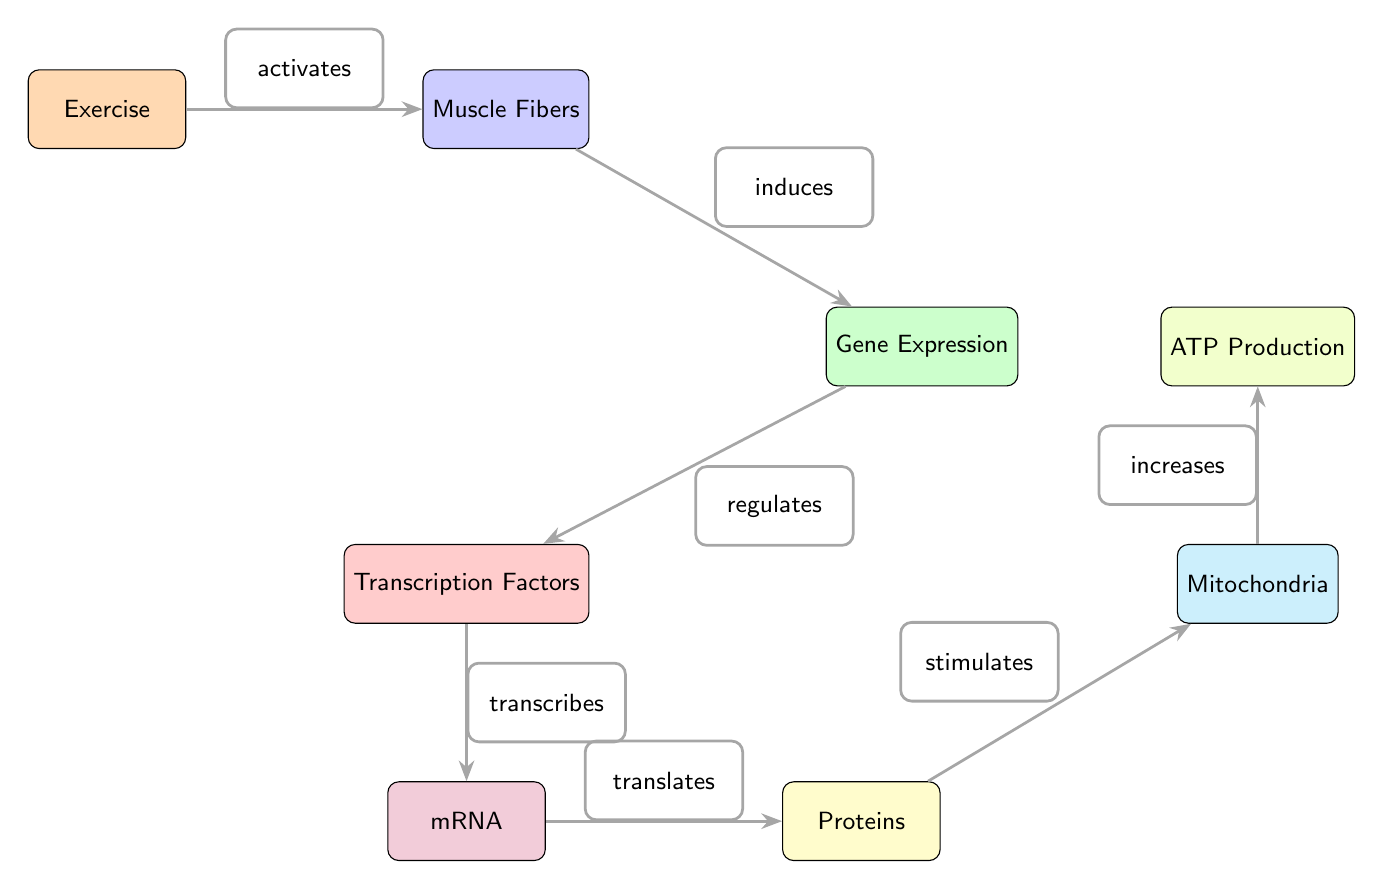What activates Muscle Fibers? The diagram indicates that Exercise activates Muscle Fibers, as depicted by the arrow connecting Exercise to Muscle Fibers with the label "activates".
Answer: Exercise What node is located directly below Gene Expression? According to the diagram, the node directly below Gene Expression is Transcription Factors, which is illustrated in the position relative to Gene Expression.
Answer: Transcription Factors How many edges are there in the diagram? Counting the connections (arrows) in the diagram, there are a total of 6 edges connecting the various nodes.
Answer: 6 Which node regulates Transcription Factors? The diagram shows that Gene Expression regulates Transcription Factors, as indicated by the arrow labeled "regulates" leading from Gene Expression to Transcription Factors.
Answer: Gene Expression What is the final outcome of the process depicted in the diagram? The last node in the diagram, as indicated by the flow of arrows, is ATP Production, which represents the final outcome after exercise triggers the entire process.
Answer: ATP Production What process occurs between mRNA and Proteins? The diagram specifies that mRNA translates to Proteins, as shown by the arrow labeled "translates" connecting these two nodes.
Answer: translates Which node is stimulated by Proteins? The diagram indicates that Mitochondria is stimulated by Proteins, as shown by the arrow labeled "stimulates" pointing from Proteins to Mitochondria.
Answer: Mitochondria What is the relationship type between Exercise and Muscle Fibers? The relationship type indicated by the diagram between Exercise and Muscle Fibers is "activates", as labeled on the connecting arrow.
Answer: activates 